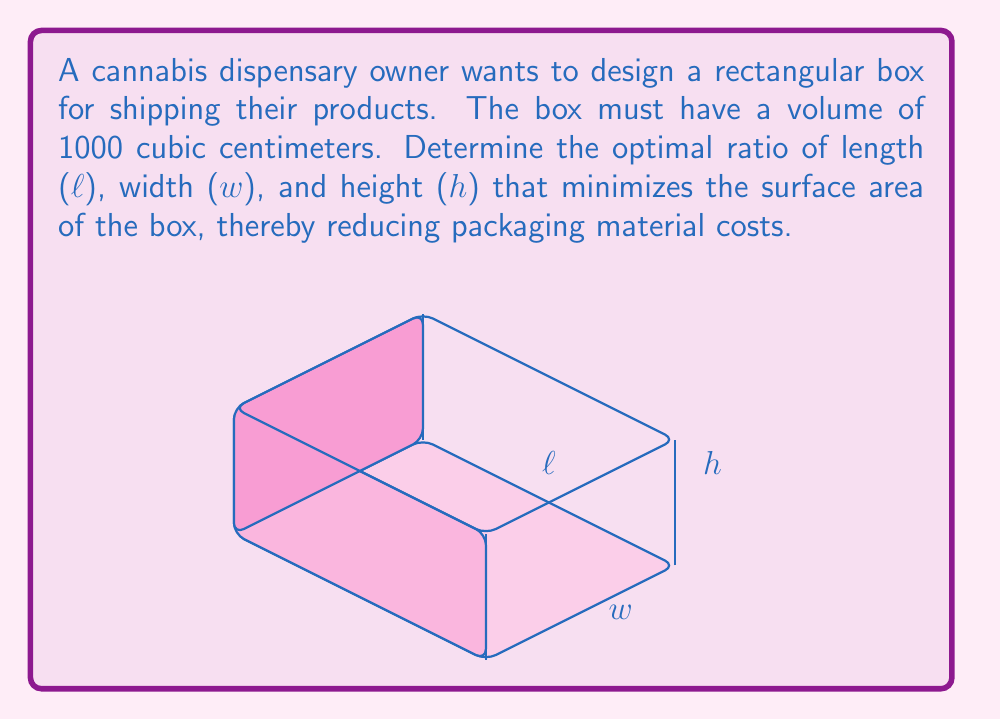Could you help me with this problem? Let's approach this step-by-step:

1) The volume of the box is given by $V = l \cdot w \cdot h = 1000$ cm³.

2) The surface area of the box is given by $S = 2(lw + lh + wh)$.

3) We need to minimize S subject to the constraint that $V = 1000$.

4) Using the method of Lagrange multipliers, we form the function:

   $F(l,w,h,\lambda) = 2(lw + lh + wh) - \lambda(lwh - 1000)$

5) Taking partial derivatives and setting them to zero:

   $\frac{\partial F}{\partial l} = 2(w + h) - \lambda wh = 0$
   $\frac{\partial F}{\partial w} = 2(l + h) - \lambda lh = 0$
   $\frac{\partial F}{\partial h} = 2(l + w) - \lambda lw = 0$
   $\frac{\partial F}{\partial \lambda} = lwh - 1000 = 0$

6) From these equations, we can deduce that $l = w = h$.

7) Substituting this into the volume equation:

   $l \cdot l \cdot l = 1000$
   $l^3 = 1000$
   $l = \sqrt[3]{1000} \approx 10$ cm

8) Therefore, the optimal ratio of length : width : height is 1 : 1 : 1.
Answer: 1 : 1 : 1 